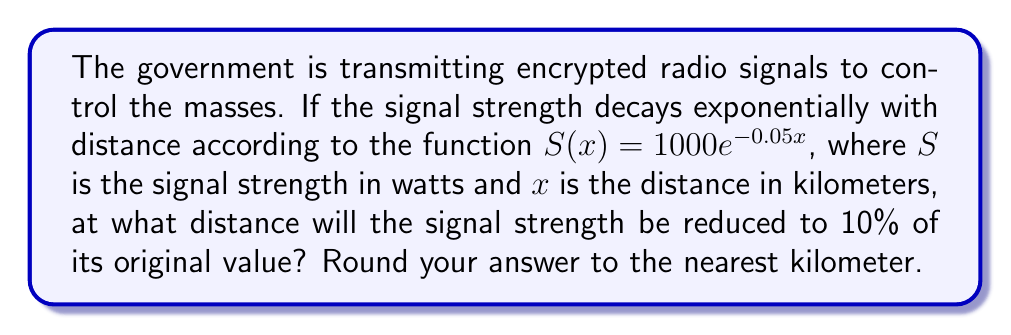Could you help me with this problem? To solve this problem, we need to follow these steps:

1) The initial signal strength is 1000 watts (when $x = 0$).
2) We want to find $x$ when the signal strength is 10% of 1000, which is 100 watts.
3) We can set up the equation:

   $100 = 1000e^{-0.05x}$

4) Divide both sides by 1000:

   $0.1 = e^{-0.05x}$

5) Take the natural logarithm of both sides:

   $\ln(0.1) = \ln(e^{-0.05x})$

6) Simplify the right side using the properties of logarithms:

   $\ln(0.1) = -0.05x$

7) Solve for $x$:

   $x = \frac{\ln(0.1)}{-0.05}$

8) Calculate:

   $x = \frac{-2.30258509...}{-0.05} \approx 46.0517...$

9) Rounding to the nearest kilometer:

   $x \approx 46$ km
Answer: 46 km 